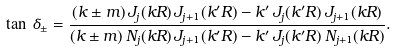<formula> <loc_0><loc_0><loc_500><loc_500>\tan \, \delta _ { \pm } = \frac { ( k \pm m ) \, J _ { j } ( k R ) \, J _ { j + 1 } ( k ^ { \prime } R ) - k ^ { \prime } \, J _ { j } ( k ^ { \prime } R ) \, J _ { j + 1 } ( k R ) } { ( k \pm m ) \, N _ { j } ( k R ) \, J _ { j + 1 } ( k ^ { \prime } R ) - k ^ { \prime } \, J _ { j } ( k ^ { \prime } R ) \, N _ { j + 1 } ( k R ) } .</formula> 